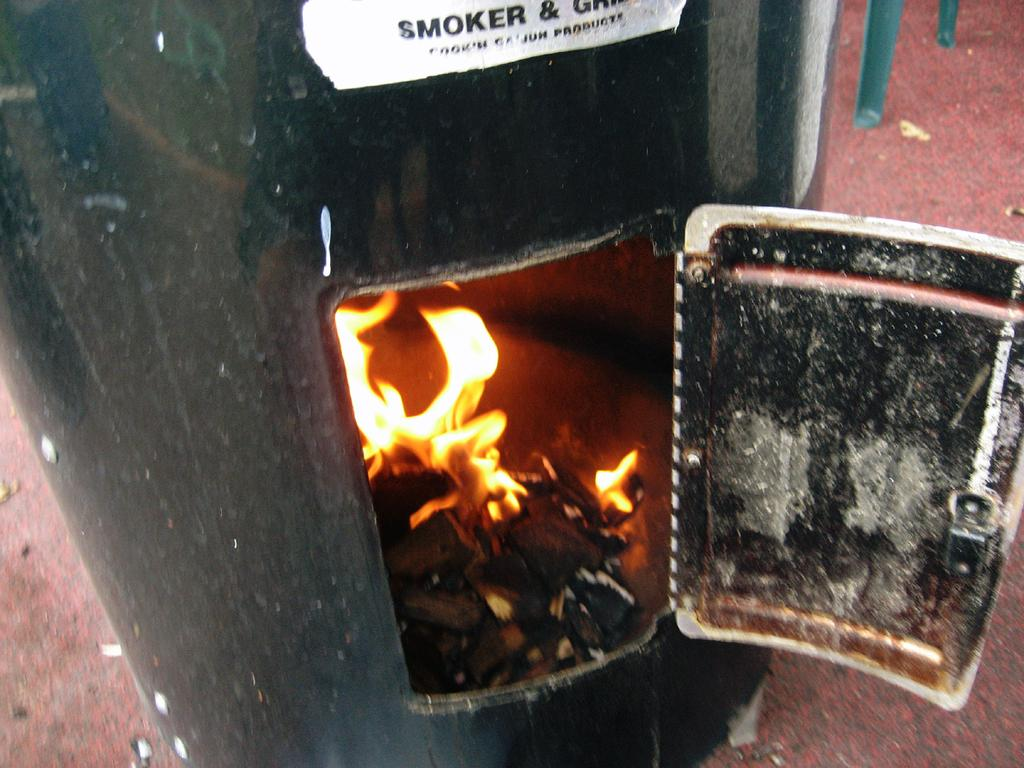What object is present in the image to prevent the fire from spreading? There is a fire screen in the image. What is the source of the fire in the image? There is a flame in the image. What material is being used to fuel the fire in the image? There is wood in the image. What is the text in the image conveying? The text in the image is not specified, but it is present. How many cakes are being prepared with the rifle in the image? There are no cakes or rifles present in the image. What type of order is being processed in the image? There is no order being processed in the image; it features a fire screen, flame, wood, and text. 